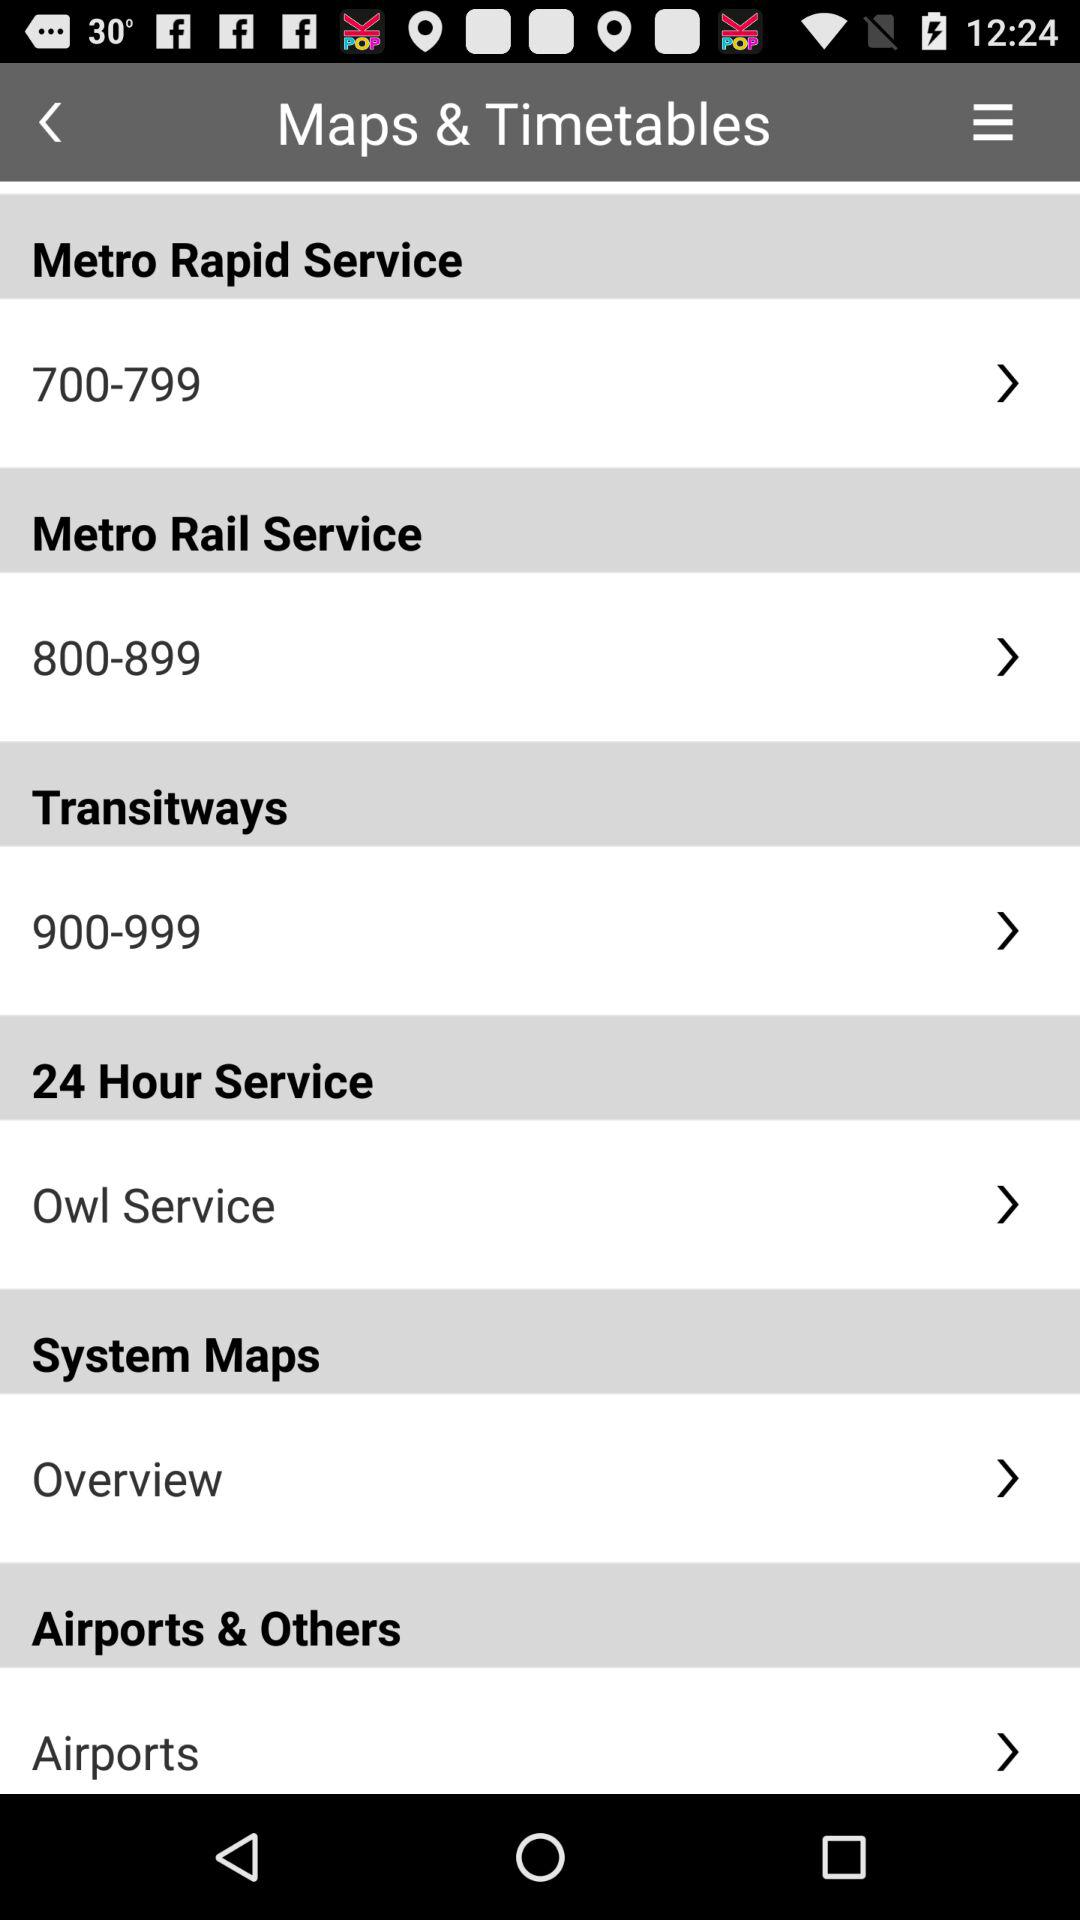Which option is selected for "Airports & Others"? The selected option is "Airports". 